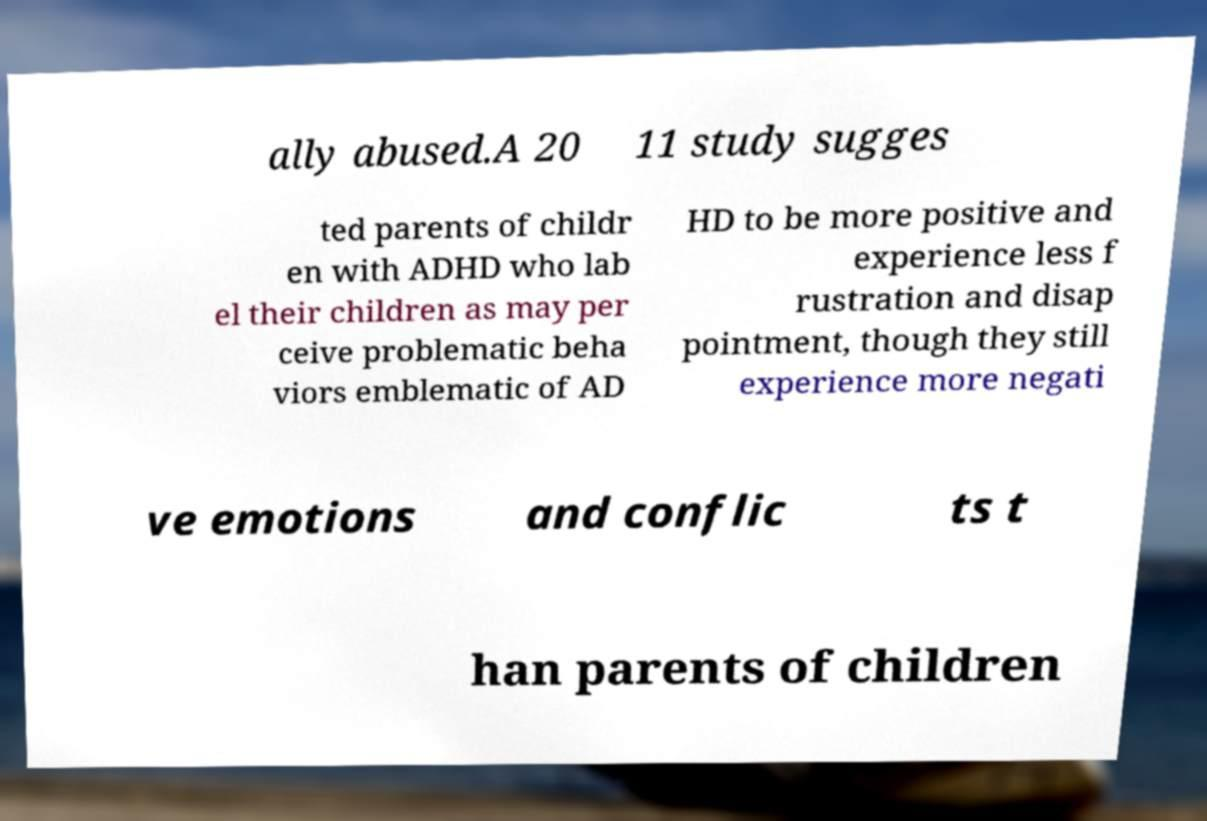Please read and relay the text visible in this image. What does it say? ally abused.A 20 11 study sugges ted parents of childr en with ADHD who lab el their children as may per ceive problematic beha viors emblematic of AD HD to be more positive and experience less f rustration and disap pointment, though they still experience more negati ve emotions and conflic ts t han parents of children 